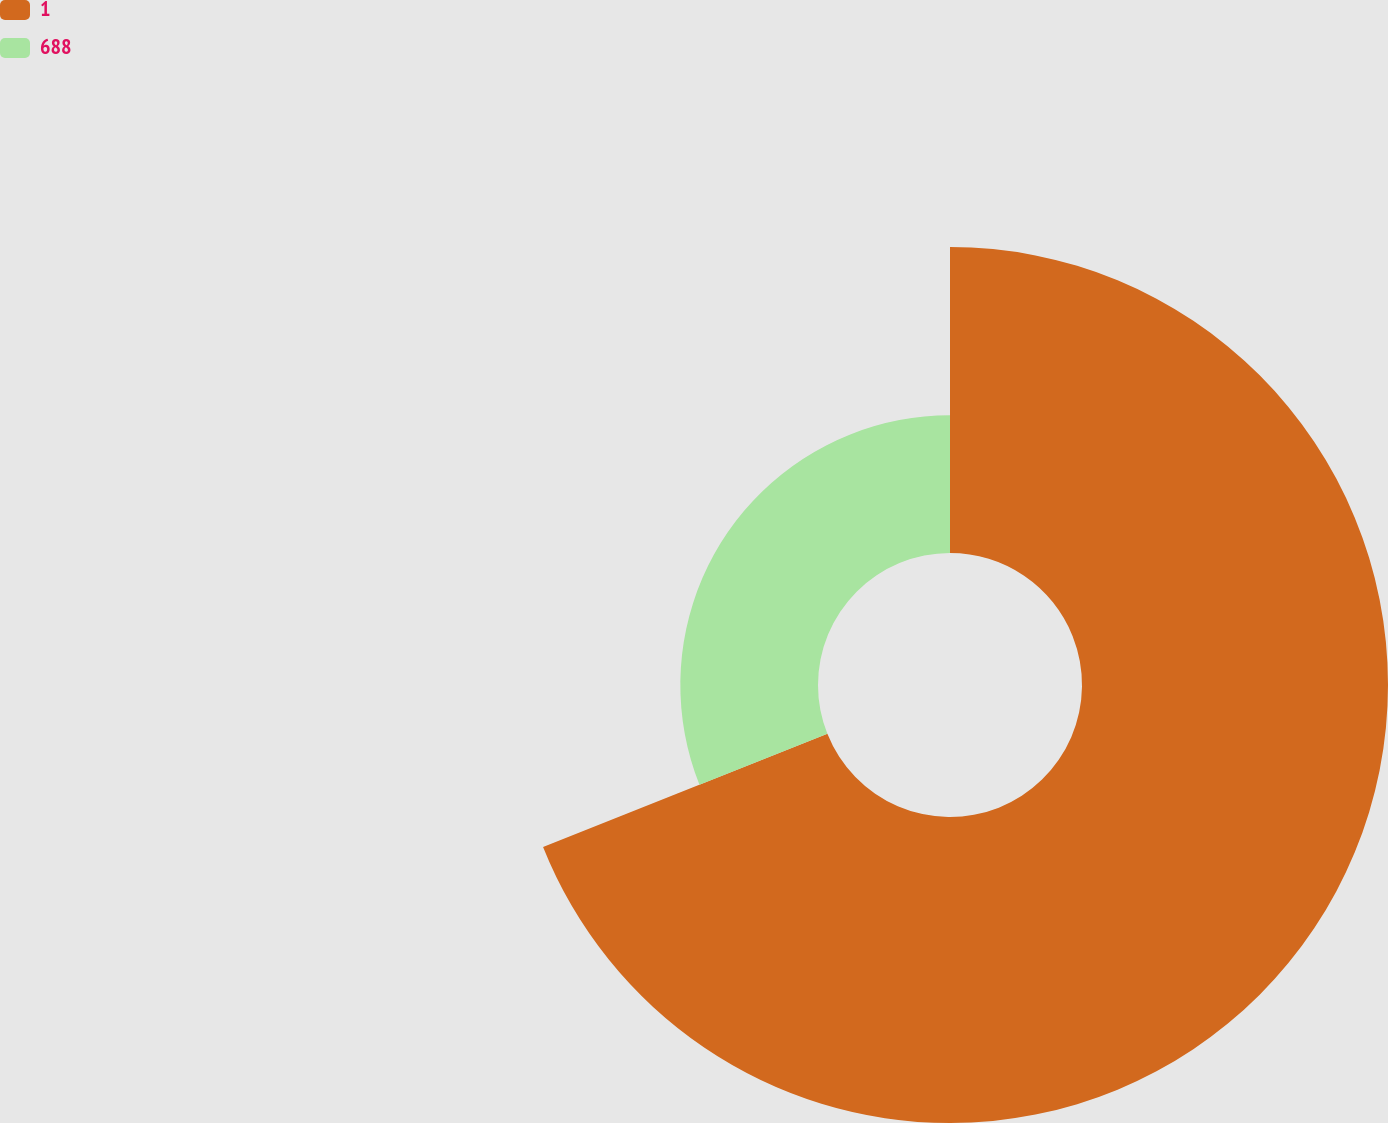Convert chart. <chart><loc_0><loc_0><loc_500><loc_500><pie_chart><fcel>1<fcel>688<nl><fcel>68.97%<fcel>31.03%<nl></chart> 